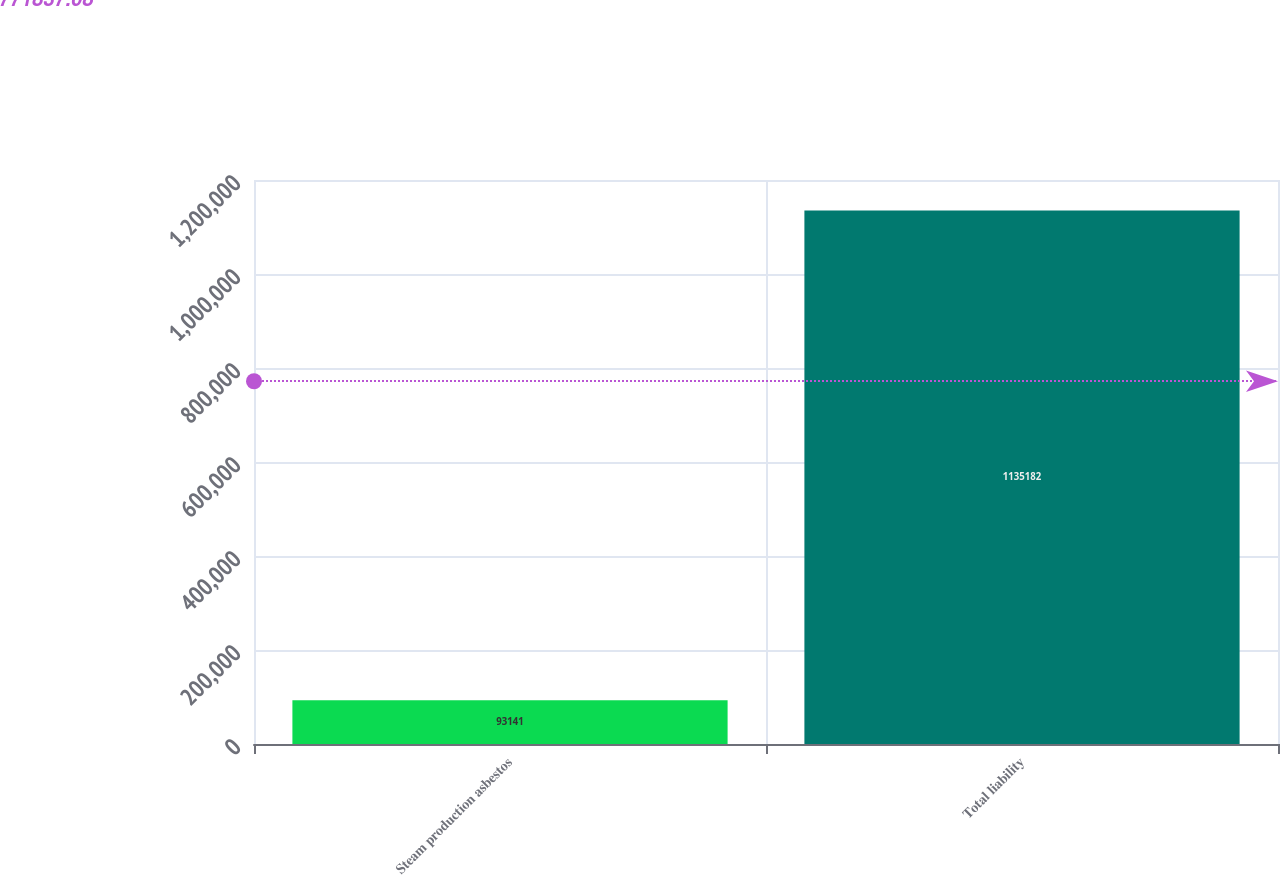Convert chart. <chart><loc_0><loc_0><loc_500><loc_500><bar_chart><fcel>Steam production asbestos<fcel>Total liability<nl><fcel>93141<fcel>1.13518e+06<nl></chart> 